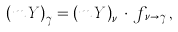<formula> <loc_0><loc_0><loc_500><loc_500>\left ( m \, Y \right ) _ { \gamma } = \left ( m \, Y \right ) _ { \nu } \, \cdot \, f _ { \, \nu \rightarrow \gamma } \, ,</formula> 